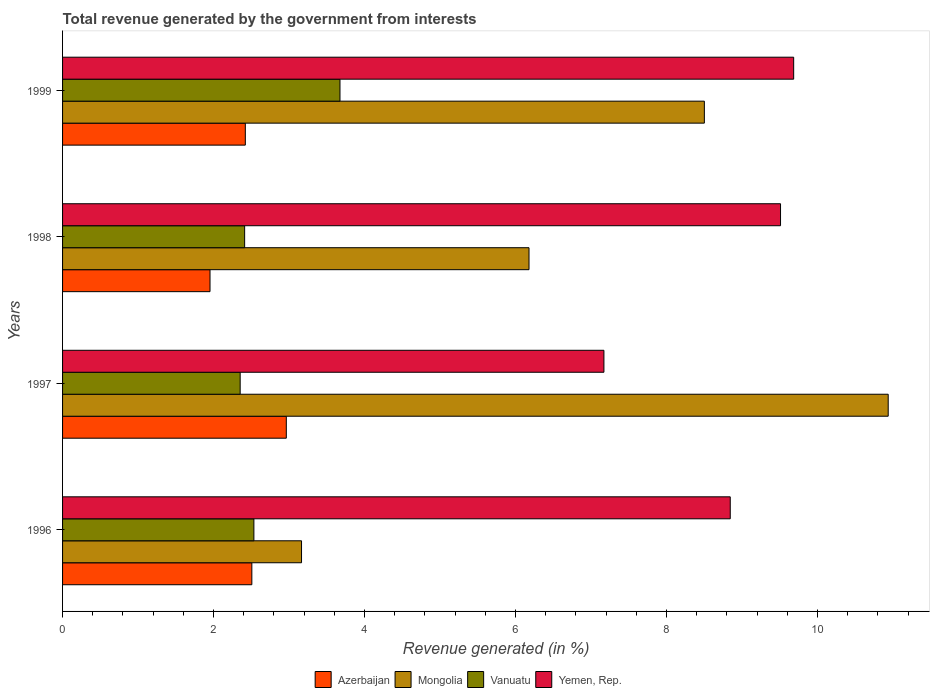How many groups of bars are there?
Give a very brief answer. 4. Are the number of bars on each tick of the Y-axis equal?
Offer a very short reply. Yes. How many bars are there on the 4th tick from the top?
Your answer should be very brief. 4. How many bars are there on the 3rd tick from the bottom?
Ensure brevity in your answer.  4. In how many cases, is the number of bars for a given year not equal to the number of legend labels?
Your response must be concise. 0. What is the total revenue generated in Mongolia in 1997?
Your answer should be very brief. 10.94. Across all years, what is the maximum total revenue generated in Vanuatu?
Provide a short and direct response. 3.68. Across all years, what is the minimum total revenue generated in Vanuatu?
Your answer should be compact. 2.35. What is the total total revenue generated in Azerbaijan in the graph?
Make the answer very short. 9.85. What is the difference between the total revenue generated in Mongolia in 1997 and that in 1998?
Your response must be concise. 4.76. What is the difference between the total revenue generated in Yemen, Rep. in 1998 and the total revenue generated in Mongolia in 1999?
Keep it short and to the point. 1.01. What is the average total revenue generated in Yemen, Rep. per year?
Provide a short and direct response. 8.8. In the year 1997, what is the difference between the total revenue generated in Yemen, Rep. and total revenue generated in Mongolia?
Provide a succinct answer. -3.77. What is the ratio of the total revenue generated in Mongolia in 1996 to that in 1997?
Offer a very short reply. 0.29. Is the difference between the total revenue generated in Yemen, Rep. in 1996 and 1997 greater than the difference between the total revenue generated in Mongolia in 1996 and 1997?
Make the answer very short. Yes. What is the difference between the highest and the second highest total revenue generated in Mongolia?
Make the answer very short. 2.44. What is the difference between the highest and the lowest total revenue generated in Vanuatu?
Your answer should be very brief. 1.32. In how many years, is the total revenue generated in Vanuatu greater than the average total revenue generated in Vanuatu taken over all years?
Your answer should be compact. 1. Is the sum of the total revenue generated in Mongolia in 1998 and 1999 greater than the maximum total revenue generated in Azerbaijan across all years?
Ensure brevity in your answer.  Yes. Is it the case that in every year, the sum of the total revenue generated in Vanuatu and total revenue generated in Mongolia is greater than the sum of total revenue generated in Yemen, Rep. and total revenue generated in Azerbaijan?
Keep it short and to the point. No. What does the 3rd bar from the top in 1998 represents?
Provide a succinct answer. Mongolia. What does the 2nd bar from the bottom in 1998 represents?
Your answer should be compact. Mongolia. Are all the bars in the graph horizontal?
Provide a succinct answer. Yes. Does the graph contain grids?
Your answer should be compact. No. Where does the legend appear in the graph?
Offer a very short reply. Bottom center. How many legend labels are there?
Your response must be concise. 4. How are the legend labels stacked?
Give a very brief answer. Horizontal. What is the title of the graph?
Keep it short and to the point. Total revenue generated by the government from interests. Does "High income" appear as one of the legend labels in the graph?
Make the answer very short. No. What is the label or title of the X-axis?
Provide a succinct answer. Revenue generated (in %). What is the Revenue generated (in %) of Azerbaijan in 1996?
Provide a succinct answer. 2.51. What is the Revenue generated (in %) of Mongolia in 1996?
Provide a succinct answer. 3.17. What is the Revenue generated (in %) in Vanuatu in 1996?
Make the answer very short. 2.53. What is the Revenue generated (in %) in Yemen, Rep. in 1996?
Your response must be concise. 8.85. What is the Revenue generated (in %) of Azerbaijan in 1997?
Keep it short and to the point. 2.96. What is the Revenue generated (in %) of Mongolia in 1997?
Provide a succinct answer. 10.94. What is the Revenue generated (in %) in Vanuatu in 1997?
Provide a short and direct response. 2.35. What is the Revenue generated (in %) of Yemen, Rep. in 1997?
Keep it short and to the point. 7.17. What is the Revenue generated (in %) in Azerbaijan in 1998?
Give a very brief answer. 1.95. What is the Revenue generated (in %) of Mongolia in 1998?
Your answer should be compact. 6.18. What is the Revenue generated (in %) of Vanuatu in 1998?
Make the answer very short. 2.41. What is the Revenue generated (in %) in Yemen, Rep. in 1998?
Ensure brevity in your answer.  9.51. What is the Revenue generated (in %) in Azerbaijan in 1999?
Offer a terse response. 2.42. What is the Revenue generated (in %) in Mongolia in 1999?
Ensure brevity in your answer.  8.5. What is the Revenue generated (in %) of Vanuatu in 1999?
Provide a succinct answer. 3.68. What is the Revenue generated (in %) of Yemen, Rep. in 1999?
Offer a terse response. 9.69. Across all years, what is the maximum Revenue generated (in %) in Azerbaijan?
Your response must be concise. 2.96. Across all years, what is the maximum Revenue generated (in %) of Mongolia?
Give a very brief answer. 10.94. Across all years, what is the maximum Revenue generated (in %) of Vanuatu?
Provide a short and direct response. 3.68. Across all years, what is the maximum Revenue generated (in %) of Yemen, Rep.?
Keep it short and to the point. 9.69. Across all years, what is the minimum Revenue generated (in %) of Azerbaijan?
Give a very brief answer. 1.95. Across all years, what is the minimum Revenue generated (in %) in Mongolia?
Keep it short and to the point. 3.17. Across all years, what is the minimum Revenue generated (in %) of Vanuatu?
Offer a very short reply. 2.35. Across all years, what is the minimum Revenue generated (in %) of Yemen, Rep.?
Ensure brevity in your answer.  7.17. What is the total Revenue generated (in %) in Azerbaijan in the graph?
Offer a very short reply. 9.85. What is the total Revenue generated (in %) in Mongolia in the graph?
Offer a terse response. 28.78. What is the total Revenue generated (in %) of Vanuatu in the graph?
Keep it short and to the point. 10.97. What is the total Revenue generated (in %) in Yemen, Rep. in the graph?
Your answer should be very brief. 35.21. What is the difference between the Revenue generated (in %) of Azerbaijan in 1996 and that in 1997?
Ensure brevity in your answer.  -0.46. What is the difference between the Revenue generated (in %) in Mongolia in 1996 and that in 1997?
Your answer should be very brief. -7.77. What is the difference between the Revenue generated (in %) in Vanuatu in 1996 and that in 1997?
Offer a very short reply. 0.18. What is the difference between the Revenue generated (in %) of Yemen, Rep. in 1996 and that in 1997?
Your answer should be compact. 1.67. What is the difference between the Revenue generated (in %) in Azerbaijan in 1996 and that in 1998?
Provide a succinct answer. 0.55. What is the difference between the Revenue generated (in %) in Mongolia in 1996 and that in 1998?
Give a very brief answer. -3.01. What is the difference between the Revenue generated (in %) of Vanuatu in 1996 and that in 1998?
Give a very brief answer. 0.12. What is the difference between the Revenue generated (in %) in Yemen, Rep. in 1996 and that in 1998?
Your answer should be very brief. -0.67. What is the difference between the Revenue generated (in %) in Azerbaijan in 1996 and that in 1999?
Your answer should be very brief. 0.09. What is the difference between the Revenue generated (in %) of Mongolia in 1996 and that in 1999?
Give a very brief answer. -5.34. What is the difference between the Revenue generated (in %) of Vanuatu in 1996 and that in 1999?
Your answer should be compact. -1.14. What is the difference between the Revenue generated (in %) in Yemen, Rep. in 1996 and that in 1999?
Your response must be concise. -0.84. What is the difference between the Revenue generated (in %) of Azerbaijan in 1997 and that in 1998?
Provide a succinct answer. 1.01. What is the difference between the Revenue generated (in %) in Mongolia in 1997 and that in 1998?
Provide a succinct answer. 4.76. What is the difference between the Revenue generated (in %) in Vanuatu in 1997 and that in 1998?
Make the answer very short. -0.06. What is the difference between the Revenue generated (in %) in Yemen, Rep. in 1997 and that in 1998?
Provide a short and direct response. -2.34. What is the difference between the Revenue generated (in %) in Azerbaijan in 1997 and that in 1999?
Your response must be concise. 0.54. What is the difference between the Revenue generated (in %) of Mongolia in 1997 and that in 1999?
Your answer should be very brief. 2.44. What is the difference between the Revenue generated (in %) of Vanuatu in 1997 and that in 1999?
Your answer should be very brief. -1.32. What is the difference between the Revenue generated (in %) in Yemen, Rep. in 1997 and that in 1999?
Keep it short and to the point. -2.51. What is the difference between the Revenue generated (in %) of Azerbaijan in 1998 and that in 1999?
Keep it short and to the point. -0.47. What is the difference between the Revenue generated (in %) in Mongolia in 1998 and that in 1999?
Provide a succinct answer. -2.32. What is the difference between the Revenue generated (in %) in Vanuatu in 1998 and that in 1999?
Provide a short and direct response. -1.26. What is the difference between the Revenue generated (in %) of Yemen, Rep. in 1998 and that in 1999?
Give a very brief answer. -0.17. What is the difference between the Revenue generated (in %) in Azerbaijan in 1996 and the Revenue generated (in %) in Mongolia in 1997?
Your answer should be very brief. -8.43. What is the difference between the Revenue generated (in %) in Azerbaijan in 1996 and the Revenue generated (in %) in Vanuatu in 1997?
Ensure brevity in your answer.  0.15. What is the difference between the Revenue generated (in %) of Azerbaijan in 1996 and the Revenue generated (in %) of Yemen, Rep. in 1997?
Offer a very short reply. -4.66. What is the difference between the Revenue generated (in %) of Mongolia in 1996 and the Revenue generated (in %) of Vanuatu in 1997?
Offer a very short reply. 0.81. What is the difference between the Revenue generated (in %) in Mongolia in 1996 and the Revenue generated (in %) in Yemen, Rep. in 1997?
Your answer should be compact. -4.01. What is the difference between the Revenue generated (in %) in Vanuatu in 1996 and the Revenue generated (in %) in Yemen, Rep. in 1997?
Make the answer very short. -4.64. What is the difference between the Revenue generated (in %) in Azerbaijan in 1996 and the Revenue generated (in %) in Mongolia in 1998?
Your answer should be very brief. -3.67. What is the difference between the Revenue generated (in %) of Azerbaijan in 1996 and the Revenue generated (in %) of Vanuatu in 1998?
Your response must be concise. 0.1. What is the difference between the Revenue generated (in %) in Azerbaijan in 1996 and the Revenue generated (in %) in Yemen, Rep. in 1998?
Offer a very short reply. -7. What is the difference between the Revenue generated (in %) in Mongolia in 1996 and the Revenue generated (in %) in Vanuatu in 1998?
Offer a very short reply. 0.75. What is the difference between the Revenue generated (in %) in Mongolia in 1996 and the Revenue generated (in %) in Yemen, Rep. in 1998?
Your answer should be compact. -6.35. What is the difference between the Revenue generated (in %) in Vanuatu in 1996 and the Revenue generated (in %) in Yemen, Rep. in 1998?
Provide a short and direct response. -6.98. What is the difference between the Revenue generated (in %) in Azerbaijan in 1996 and the Revenue generated (in %) in Mongolia in 1999?
Give a very brief answer. -5.99. What is the difference between the Revenue generated (in %) of Azerbaijan in 1996 and the Revenue generated (in %) of Vanuatu in 1999?
Keep it short and to the point. -1.17. What is the difference between the Revenue generated (in %) of Azerbaijan in 1996 and the Revenue generated (in %) of Yemen, Rep. in 1999?
Offer a terse response. -7.18. What is the difference between the Revenue generated (in %) in Mongolia in 1996 and the Revenue generated (in %) in Vanuatu in 1999?
Provide a succinct answer. -0.51. What is the difference between the Revenue generated (in %) of Mongolia in 1996 and the Revenue generated (in %) of Yemen, Rep. in 1999?
Your answer should be very brief. -6.52. What is the difference between the Revenue generated (in %) of Vanuatu in 1996 and the Revenue generated (in %) of Yemen, Rep. in 1999?
Make the answer very short. -7.15. What is the difference between the Revenue generated (in %) in Azerbaijan in 1997 and the Revenue generated (in %) in Mongolia in 1998?
Ensure brevity in your answer.  -3.22. What is the difference between the Revenue generated (in %) of Azerbaijan in 1997 and the Revenue generated (in %) of Vanuatu in 1998?
Ensure brevity in your answer.  0.55. What is the difference between the Revenue generated (in %) in Azerbaijan in 1997 and the Revenue generated (in %) in Yemen, Rep. in 1998?
Ensure brevity in your answer.  -6.55. What is the difference between the Revenue generated (in %) of Mongolia in 1997 and the Revenue generated (in %) of Vanuatu in 1998?
Make the answer very short. 8.53. What is the difference between the Revenue generated (in %) in Mongolia in 1997 and the Revenue generated (in %) in Yemen, Rep. in 1998?
Provide a short and direct response. 1.43. What is the difference between the Revenue generated (in %) in Vanuatu in 1997 and the Revenue generated (in %) in Yemen, Rep. in 1998?
Keep it short and to the point. -7.16. What is the difference between the Revenue generated (in %) of Azerbaijan in 1997 and the Revenue generated (in %) of Mongolia in 1999?
Keep it short and to the point. -5.54. What is the difference between the Revenue generated (in %) in Azerbaijan in 1997 and the Revenue generated (in %) in Vanuatu in 1999?
Keep it short and to the point. -0.71. What is the difference between the Revenue generated (in %) in Azerbaijan in 1997 and the Revenue generated (in %) in Yemen, Rep. in 1999?
Ensure brevity in your answer.  -6.72. What is the difference between the Revenue generated (in %) in Mongolia in 1997 and the Revenue generated (in %) in Vanuatu in 1999?
Your answer should be compact. 7.26. What is the difference between the Revenue generated (in %) in Mongolia in 1997 and the Revenue generated (in %) in Yemen, Rep. in 1999?
Keep it short and to the point. 1.25. What is the difference between the Revenue generated (in %) of Vanuatu in 1997 and the Revenue generated (in %) of Yemen, Rep. in 1999?
Offer a terse response. -7.33. What is the difference between the Revenue generated (in %) in Azerbaijan in 1998 and the Revenue generated (in %) in Mongolia in 1999?
Ensure brevity in your answer.  -6.55. What is the difference between the Revenue generated (in %) in Azerbaijan in 1998 and the Revenue generated (in %) in Vanuatu in 1999?
Keep it short and to the point. -1.72. What is the difference between the Revenue generated (in %) in Azerbaijan in 1998 and the Revenue generated (in %) in Yemen, Rep. in 1999?
Your answer should be compact. -7.73. What is the difference between the Revenue generated (in %) in Mongolia in 1998 and the Revenue generated (in %) in Vanuatu in 1999?
Your response must be concise. 2.5. What is the difference between the Revenue generated (in %) in Mongolia in 1998 and the Revenue generated (in %) in Yemen, Rep. in 1999?
Provide a succinct answer. -3.51. What is the difference between the Revenue generated (in %) of Vanuatu in 1998 and the Revenue generated (in %) of Yemen, Rep. in 1999?
Make the answer very short. -7.27. What is the average Revenue generated (in %) in Azerbaijan per year?
Give a very brief answer. 2.46. What is the average Revenue generated (in %) of Mongolia per year?
Your answer should be compact. 7.2. What is the average Revenue generated (in %) of Vanuatu per year?
Your answer should be compact. 2.74. What is the average Revenue generated (in %) in Yemen, Rep. per year?
Provide a short and direct response. 8.8. In the year 1996, what is the difference between the Revenue generated (in %) in Azerbaijan and Revenue generated (in %) in Mongolia?
Your answer should be compact. -0.66. In the year 1996, what is the difference between the Revenue generated (in %) in Azerbaijan and Revenue generated (in %) in Vanuatu?
Your answer should be compact. -0.03. In the year 1996, what is the difference between the Revenue generated (in %) of Azerbaijan and Revenue generated (in %) of Yemen, Rep.?
Your response must be concise. -6.34. In the year 1996, what is the difference between the Revenue generated (in %) in Mongolia and Revenue generated (in %) in Vanuatu?
Your response must be concise. 0.63. In the year 1996, what is the difference between the Revenue generated (in %) in Mongolia and Revenue generated (in %) in Yemen, Rep.?
Make the answer very short. -5.68. In the year 1996, what is the difference between the Revenue generated (in %) of Vanuatu and Revenue generated (in %) of Yemen, Rep.?
Provide a succinct answer. -6.31. In the year 1997, what is the difference between the Revenue generated (in %) of Azerbaijan and Revenue generated (in %) of Mongolia?
Keep it short and to the point. -7.97. In the year 1997, what is the difference between the Revenue generated (in %) in Azerbaijan and Revenue generated (in %) in Vanuatu?
Your answer should be very brief. 0.61. In the year 1997, what is the difference between the Revenue generated (in %) of Azerbaijan and Revenue generated (in %) of Yemen, Rep.?
Provide a short and direct response. -4.21. In the year 1997, what is the difference between the Revenue generated (in %) of Mongolia and Revenue generated (in %) of Vanuatu?
Offer a very short reply. 8.58. In the year 1997, what is the difference between the Revenue generated (in %) of Mongolia and Revenue generated (in %) of Yemen, Rep.?
Ensure brevity in your answer.  3.77. In the year 1997, what is the difference between the Revenue generated (in %) of Vanuatu and Revenue generated (in %) of Yemen, Rep.?
Ensure brevity in your answer.  -4.82. In the year 1998, what is the difference between the Revenue generated (in %) of Azerbaijan and Revenue generated (in %) of Mongolia?
Offer a very short reply. -4.23. In the year 1998, what is the difference between the Revenue generated (in %) of Azerbaijan and Revenue generated (in %) of Vanuatu?
Your response must be concise. -0.46. In the year 1998, what is the difference between the Revenue generated (in %) of Azerbaijan and Revenue generated (in %) of Yemen, Rep.?
Your answer should be very brief. -7.56. In the year 1998, what is the difference between the Revenue generated (in %) in Mongolia and Revenue generated (in %) in Vanuatu?
Offer a very short reply. 3.77. In the year 1998, what is the difference between the Revenue generated (in %) in Mongolia and Revenue generated (in %) in Yemen, Rep.?
Give a very brief answer. -3.33. In the year 1998, what is the difference between the Revenue generated (in %) of Vanuatu and Revenue generated (in %) of Yemen, Rep.?
Ensure brevity in your answer.  -7.1. In the year 1999, what is the difference between the Revenue generated (in %) in Azerbaijan and Revenue generated (in %) in Mongolia?
Offer a very short reply. -6.08. In the year 1999, what is the difference between the Revenue generated (in %) of Azerbaijan and Revenue generated (in %) of Vanuatu?
Give a very brief answer. -1.25. In the year 1999, what is the difference between the Revenue generated (in %) in Azerbaijan and Revenue generated (in %) in Yemen, Rep.?
Your answer should be compact. -7.26. In the year 1999, what is the difference between the Revenue generated (in %) of Mongolia and Revenue generated (in %) of Vanuatu?
Offer a very short reply. 4.83. In the year 1999, what is the difference between the Revenue generated (in %) of Mongolia and Revenue generated (in %) of Yemen, Rep.?
Ensure brevity in your answer.  -1.18. In the year 1999, what is the difference between the Revenue generated (in %) of Vanuatu and Revenue generated (in %) of Yemen, Rep.?
Keep it short and to the point. -6.01. What is the ratio of the Revenue generated (in %) in Azerbaijan in 1996 to that in 1997?
Give a very brief answer. 0.85. What is the ratio of the Revenue generated (in %) of Mongolia in 1996 to that in 1997?
Provide a succinct answer. 0.29. What is the ratio of the Revenue generated (in %) in Vanuatu in 1996 to that in 1997?
Make the answer very short. 1.08. What is the ratio of the Revenue generated (in %) of Yemen, Rep. in 1996 to that in 1997?
Provide a short and direct response. 1.23. What is the ratio of the Revenue generated (in %) in Azerbaijan in 1996 to that in 1998?
Your answer should be very brief. 1.28. What is the ratio of the Revenue generated (in %) of Mongolia in 1996 to that in 1998?
Keep it short and to the point. 0.51. What is the ratio of the Revenue generated (in %) in Vanuatu in 1996 to that in 1998?
Your answer should be compact. 1.05. What is the ratio of the Revenue generated (in %) in Yemen, Rep. in 1996 to that in 1998?
Offer a very short reply. 0.93. What is the ratio of the Revenue generated (in %) of Azerbaijan in 1996 to that in 1999?
Your answer should be compact. 1.04. What is the ratio of the Revenue generated (in %) of Mongolia in 1996 to that in 1999?
Your answer should be compact. 0.37. What is the ratio of the Revenue generated (in %) of Vanuatu in 1996 to that in 1999?
Your answer should be very brief. 0.69. What is the ratio of the Revenue generated (in %) of Yemen, Rep. in 1996 to that in 1999?
Give a very brief answer. 0.91. What is the ratio of the Revenue generated (in %) in Azerbaijan in 1997 to that in 1998?
Make the answer very short. 1.52. What is the ratio of the Revenue generated (in %) of Mongolia in 1997 to that in 1998?
Your response must be concise. 1.77. What is the ratio of the Revenue generated (in %) of Vanuatu in 1997 to that in 1998?
Provide a succinct answer. 0.98. What is the ratio of the Revenue generated (in %) of Yemen, Rep. in 1997 to that in 1998?
Offer a terse response. 0.75. What is the ratio of the Revenue generated (in %) of Azerbaijan in 1997 to that in 1999?
Ensure brevity in your answer.  1.22. What is the ratio of the Revenue generated (in %) in Mongolia in 1997 to that in 1999?
Your response must be concise. 1.29. What is the ratio of the Revenue generated (in %) in Vanuatu in 1997 to that in 1999?
Your response must be concise. 0.64. What is the ratio of the Revenue generated (in %) in Yemen, Rep. in 1997 to that in 1999?
Keep it short and to the point. 0.74. What is the ratio of the Revenue generated (in %) of Azerbaijan in 1998 to that in 1999?
Your response must be concise. 0.81. What is the ratio of the Revenue generated (in %) in Mongolia in 1998 to that in 1999?
Your response must be concise. 0.73. What is the ratio of the Revenue generated (in %) of Vanuatu in 1998 to that in 1999?
Keep it short and to the point. 0.66. What is the difference between the highest and the second highest Revenue generated (in %) in Azerbaijan?
Your answer should be compact. 0.46. What is the difference between the highest and the second highest Revenue generated (in %) of Mongolia?
Keep it short and to the point. 2.44. What is the difference between the highest and the second highest Revenue generated (in %) of Vanuatu?
Provide a succinct answer. 1.14. What is the difference between the highest and the second highest Revenue generated (in %) in Yemen, Rep.?
Ensure brevity in your answer.  0.17. What is the difference between the highest and the lowest Revenue generated (in %) in Azerbaijan?
Offer a terse response. 1.01. What is the difference between the highest and the lowest Revenue generated (in %) of Mongolia?
Your answer should be very brief. 7.77. What is the difference between the highest and the lowest Revenue generated (in %) of Vanuatu?
Make the answer very short. 1.32. What is the difference between the highest and the lowest Revenue generated (in %) of Yemen, Rep.?
Offer a very short reply. 2.51. 